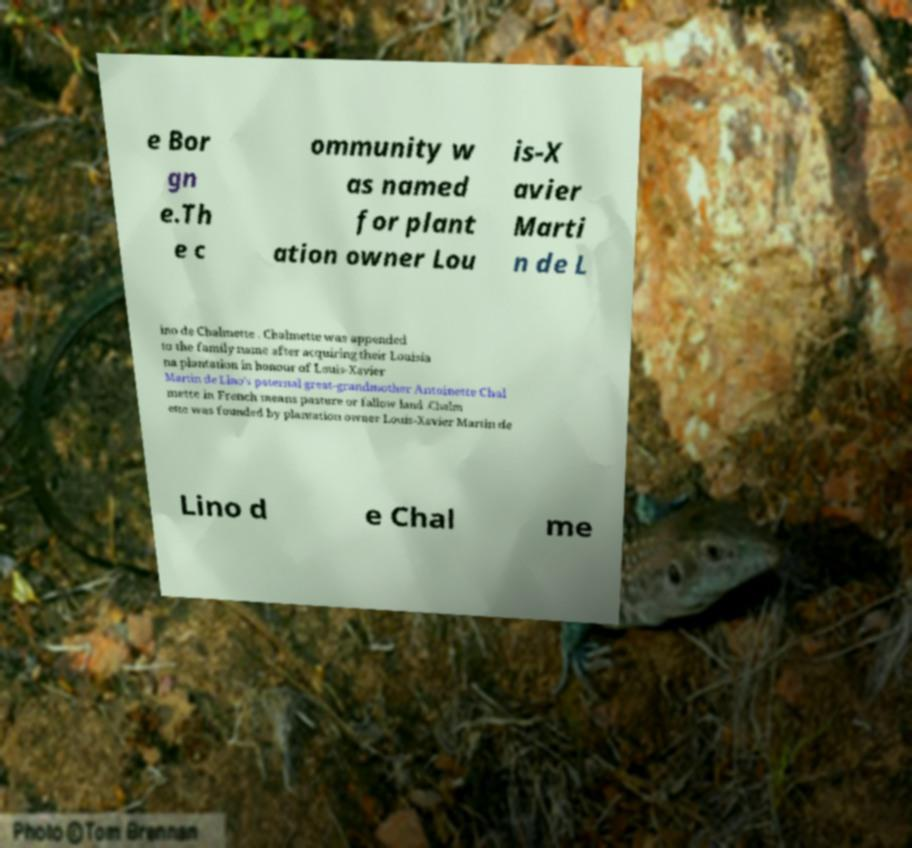There's text embedded in this image that I need extracted. Can you transcribe it verbatim? e Bor gn e.Th e c ommunity w as named for plant ation owner Lou is-X avier Marti n de L ino de Chalmette . Chalmette was appended to the family name after acquiring their Louisia na plantation in honour of Louis-Xavier Martin de Lino's paternal great-grandmother Antoinette Chal mette in French means pasture or fallow land .Chalm ette was founded by plantation owner Louis-Xavier Martin de Lino d e Chal me 